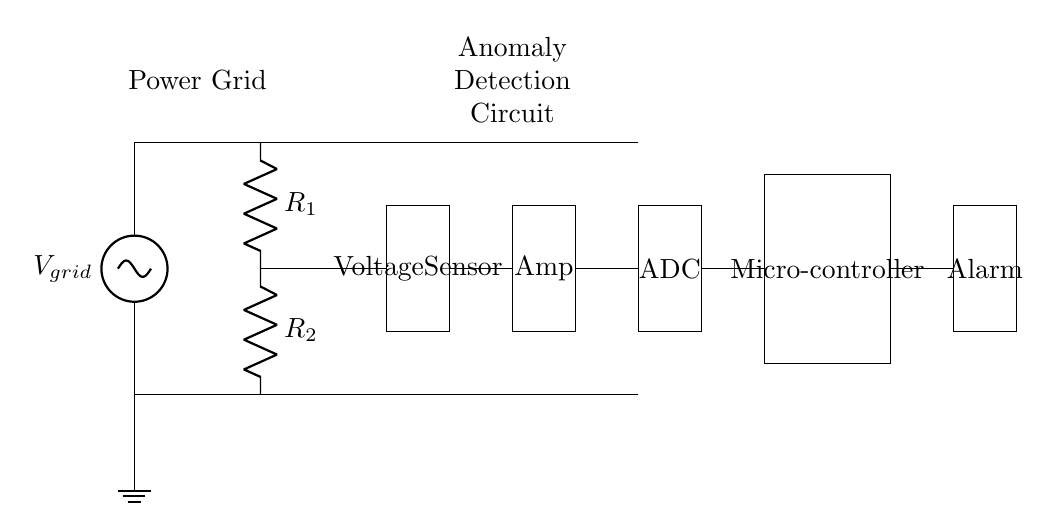What is the input voltage for the voltage divider? The input voltage for the voltage divider is the voltage from the power grid, denoted as V grid. This is the source voltage that connects to the top of the voltage divider circuit.
Answer: V grid What type of sensor is used in this circuit? The circuit employs a voltage sensor, which is designated in the diagram. It is responsible for measuring the voltage after the voltage divider, seeking to detect anomalies based on voltage levels.
Answer: Voltage sensor How many resistors are in the voltage divider? The circuit diagram indicates that there are two resistors, labeled R 1 and R 2. These resistors are used to create a voltage division to monitor voltage levels accurately.
Answer: Two What component processes the voltage signal after the sensor? The component that processes the voltage signal after the sensor is the amplifier. It amplifies the signal from the voltage sensor before sending it to the next component.
Answer: Amp What is the purpose of the ADC in the circuit? The ADC, or Analog-to-Digital Converter, is used to convert the analog signal from the amplifier into a digital format, which can be understood by the microcontroller. This conversion is crucial for digital processing and anomaly detection.
Answer: Convert analog to digital What happens after the microcontroller detects an anomaly? After detecting an anomaly, the microcontroller triggers the alarm component in the circuit, which is designed to alert users or systems to potential issues in the power grid. This is a crucial response action for any detected grid anomalies.
Answer: Triggers alarm What does the term 'anomaly detection' imply in this circuit? Anomaly detection refers to the ability of the circuit to monitor and identify unusual variations in the voltage signals, which may indicate a malfunction or threat in the energy infrastructure. This process is essential for maintaining the integrity and security of the power grid.
Answer: Identifies unusual voltage variations 